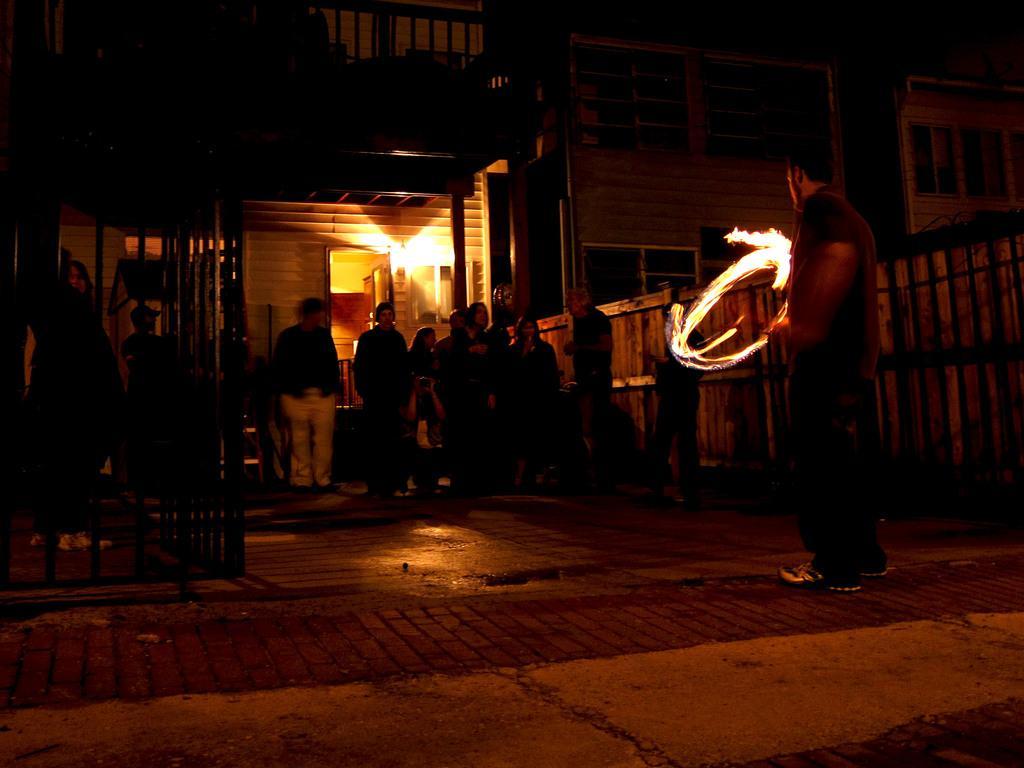In one or two sentences, can you explain what this image depicts? There is one person standing and holding a fire ring on the right side of this image, and there are some persons standing in the middle of this image, and there is a building in the background. 